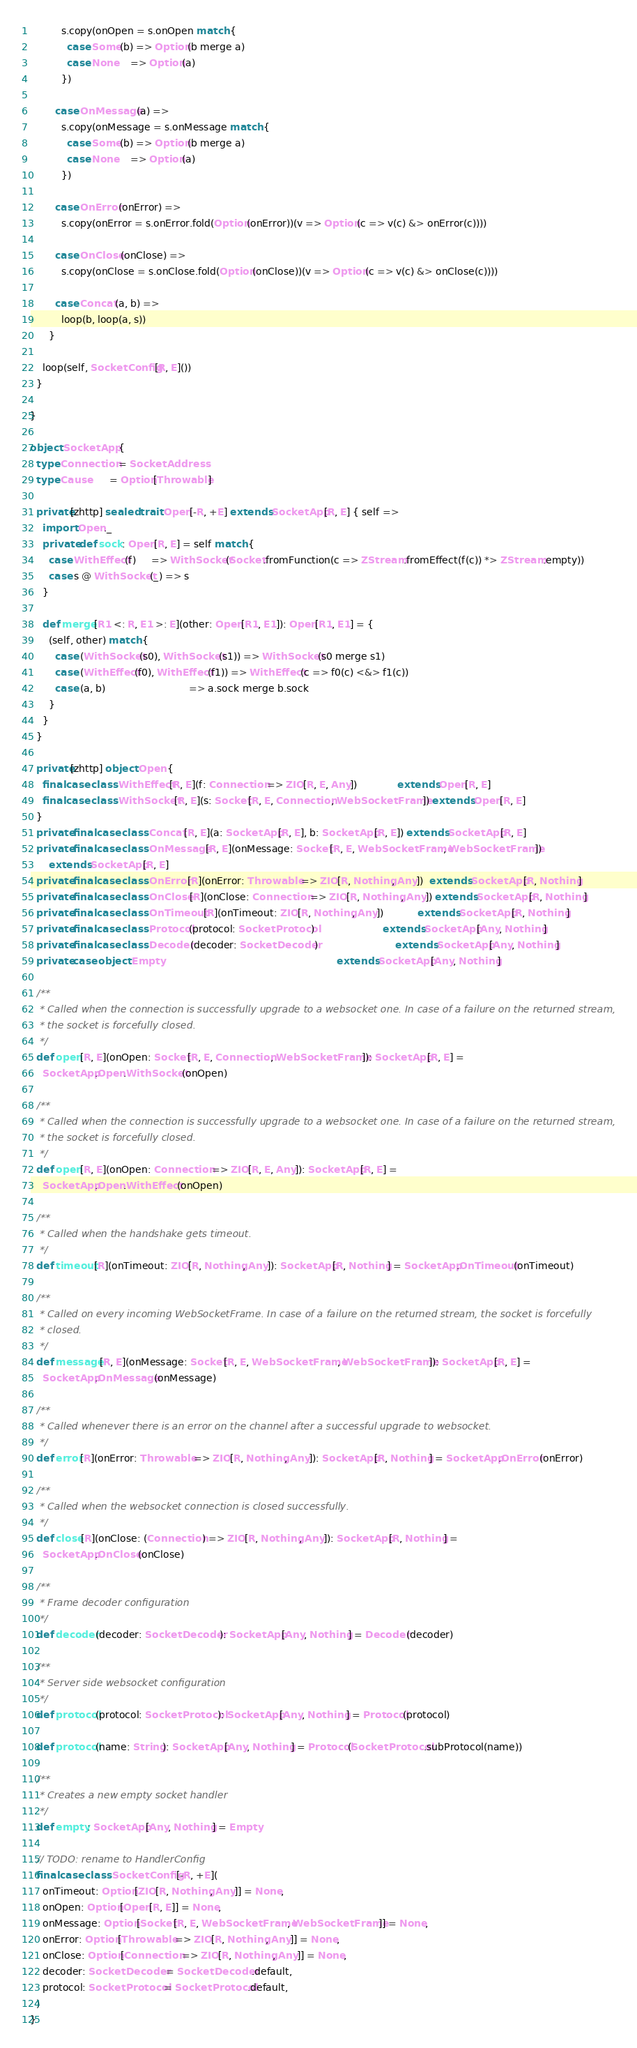Convert code to text. <code><loc_0><loc_0><loc_500><loc_500><_Scala_>          s.copy(onOpen = s.onOpen match {
            case Some(b) => Option(b merge a)
            case None    => Option(a)
          })

        case OnMessage(a) =>
          s.copy(onMessage = s.onMessage match {
            case Some(b) => Option(b merge a)
            case None    => Option(a)
          })

        case OnError(onError) =>
          s.copy(onError = s.onError.fold(Option(onError))(v => Option(c => v(c) &> onError(c))))

        case OnClose(onClose) =>
          s.copy(onClose = s.onClose.fold(Option(onClose))(v => Option(c => v(c) &> onClose(c))))

        case Concat(a, b) =>
          loop(b, loop(a, s))
      }

    loop(self, SocketConfig[R, E]())
  }

}

object SocketApp {
  type Connection = SocketAddress
  type Cause      = Option[Throwable]

  private[zhttp] sealed trait Open[-R, +E] extends SocketApp[R, E] { self =>
    import Open._
    private def sock: Open[R, E] = self match {
      case WithEffect(f)     => WithSocket(Socket.fromFunction(c => ZStream.fromEffect(f(c)) *> ZStream.empty))
      case s @ WithSocket(_) => s
    }

    def merge[R1 <: R, E1 >: E](other: Open[R1, E1]): Open[R1, E1] = {
      (self, other) match {
        case (WithSocket(s0), WithSocket(s1)) => WithSocket(s0 merge s1)
        case (WithEffect(f0), WithEffect(f1)) => WithEffect(c => f0(c) <&> f1(c))
        case (a, b)                           => a.sock merge b.sock
      }
    }
  }

  private[zhttp] object Open {
    final case class WithEffect[R, E](f: Connection => ZIO[R, E, Any])             extends Open[R, E]
    final case class WithSocket[R, E](s: Socket[R, E, Connection, WebSocketFrame]) extends Open[R, E]
  }
  private final case class Concat[R, E](a: SocketApp[R, E], b: SocketApp[R, E]) extends SocketApp[R, E]
  private final case class OnMessage[R, E](onMessage: Socket[R, E, WebSocketFrame, WebSocketFrame])
      extends SocketApp[R, E]
  private final case class OnError[R](onError: Throwable => ZIO[R, Nothing, Any])  extends SocketApp[R, Nothing]
  private final case class OnClose[R](onClose: Connection => ZIO[R, Nothing, Any]) extends SocketApp[R, Nothing]
  private final case class OnTimeout[R](onTimeout: ZIO[R, Nothing, Any])           extends SocketApp[R, Nothing]
  private final case class Protocol(protocol: SocketProtocol)                      extends SocketApp[Any, Nothing]
  private final case class Decoder(decoder: SocketDecoder)                         extends SocketApp[Any, Nothing]
  private case object Empty                                                        extends SocketApp[Any, Nothing]

  /**
   * Called when the connection is successfully upgrade to a websocket one. In case of a failure on the returned stream,
   * the socket is forcefully closed.
   */
  def open[R, E](onOpen: Socket[R, E, Connection, WebSocketFrame]): SocketApp[R, E] =
    SocketApp.Open.WithSocket(onOpen)

  /**
   * Called when the connection is successfully upgrade to a websocket one. In case of a failure on the returned stream,
   * the socket is forcefully closed.
   */
  def open[R, E](onOpen: Connection => ZIO[R, E, Any]): SocketApp[R, E] =
    SocketApp.Open.WithEffect(onOpen)

  /**
   * Called when the handshake gets timeout.
   */
  def timeout[R](onTimeout: ZIO[R, Nothing, Any]): SocketApp[R, Nothing] = SocketApp.OnTimeout(onTimeout)

  /**
   * Called on every incoming WebSocketFrame. In case of a failure on the returned stream, the socket is forcefully
   * closed.
   */
  def message[R, E](onMessage: Socket[R, E, WebSocketFrame, WebSocketFrame]): SocketApp[R, E] =
    SocketApp.OnMessage(onMessage)

  /**
   * Called whenever there is an error on the channel after a successful upgrade to websocket.
   */
  def error[R](onError: Throwable => ZIO[R, Nothing, Any]): SocketApp[R, Nothing] = SocketApp.OnError(onError)

  /**
   * Called when the websocket connection is closed successfully.
   */
  def close[R](onClose: (Connection) => ZIO[R, Nothing, Any]): SocketApp[R, Nothing] =
    SocketApp.OnClose(onClose)

  /**
   * Frame decoder configuration
   */
  def decoder(decoder: SocketDecoder): SocketApp[Any, Nothing] = Decoder(decoder)

  /**
   * Server side websocket configuration
   */
  def protocol(protocol: SocketProtocol): SocketApp[Any, Nothing] = Protocol(protocol)

  def protocol(name: String): SocketApp[Any, Nothing] = Protocol(SocketProtocol.subProtocol(name))

  /**
   * Creates a new empty socket handler
   */
  def empty: SocketApp[Any, Nothing] = Empty

  // TODO: rename to HandlerConfig
  final case class SocketConfig[-R, +E](
    onTimeout: Option[ZIO[R, Nothing, Any]] = None,
    onOpen: Option[Open[R, E]] = None,
    onMessage: Option[Socket[R, E, WebSocketFrame, WebSocketFrame]] = None,
    onError: Option[Throwable => ZIO[R, Nothing, Any]] = None,
    onClose: Option[Connection => ZIO[R, Nothing, Any]] = None,
    decoder: SocketDecoder = SocketDecoder.default,
    protocol: SocketProtocol = SocketProtocol.default,
  )
}
</code> 